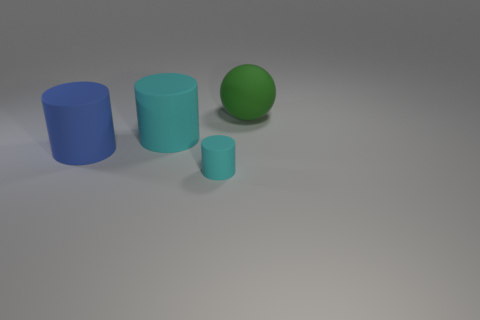Add 1 cyan objects. How many objects exist? 5 Subtract all balls. How many objects are left? 3 Subtract all metal objects. Subtract all cyan matte things. How many objects are left? 2 Add 3 cylinders. How many cylinders are left? 6 Add 1 large brown metallic objects. How many large brown metallic objects exist? 1 Subtract 0 green blocks. How many objects are left? 4 